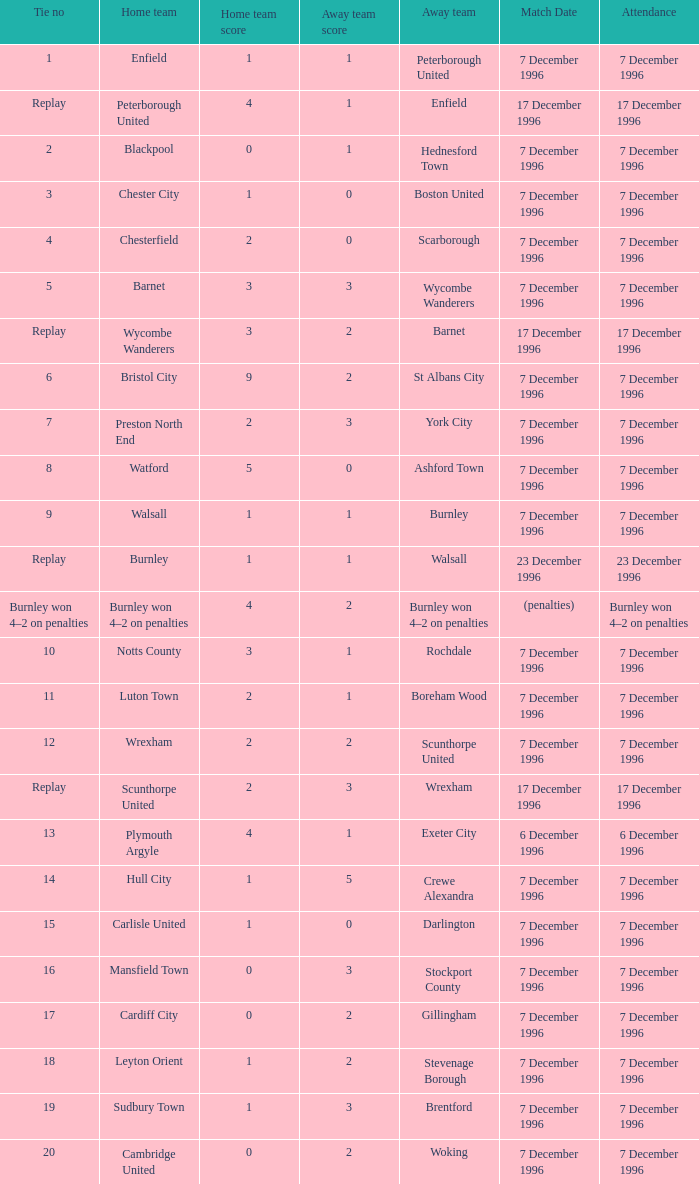What was the number of attendees for walsall's home team? 7 December 1996. 